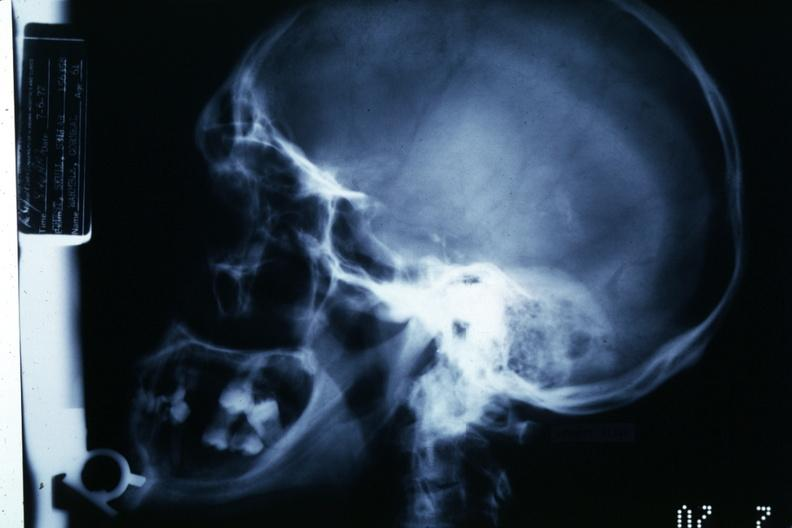s bone, skull present?
Answer the question using a single word or phrase. No 